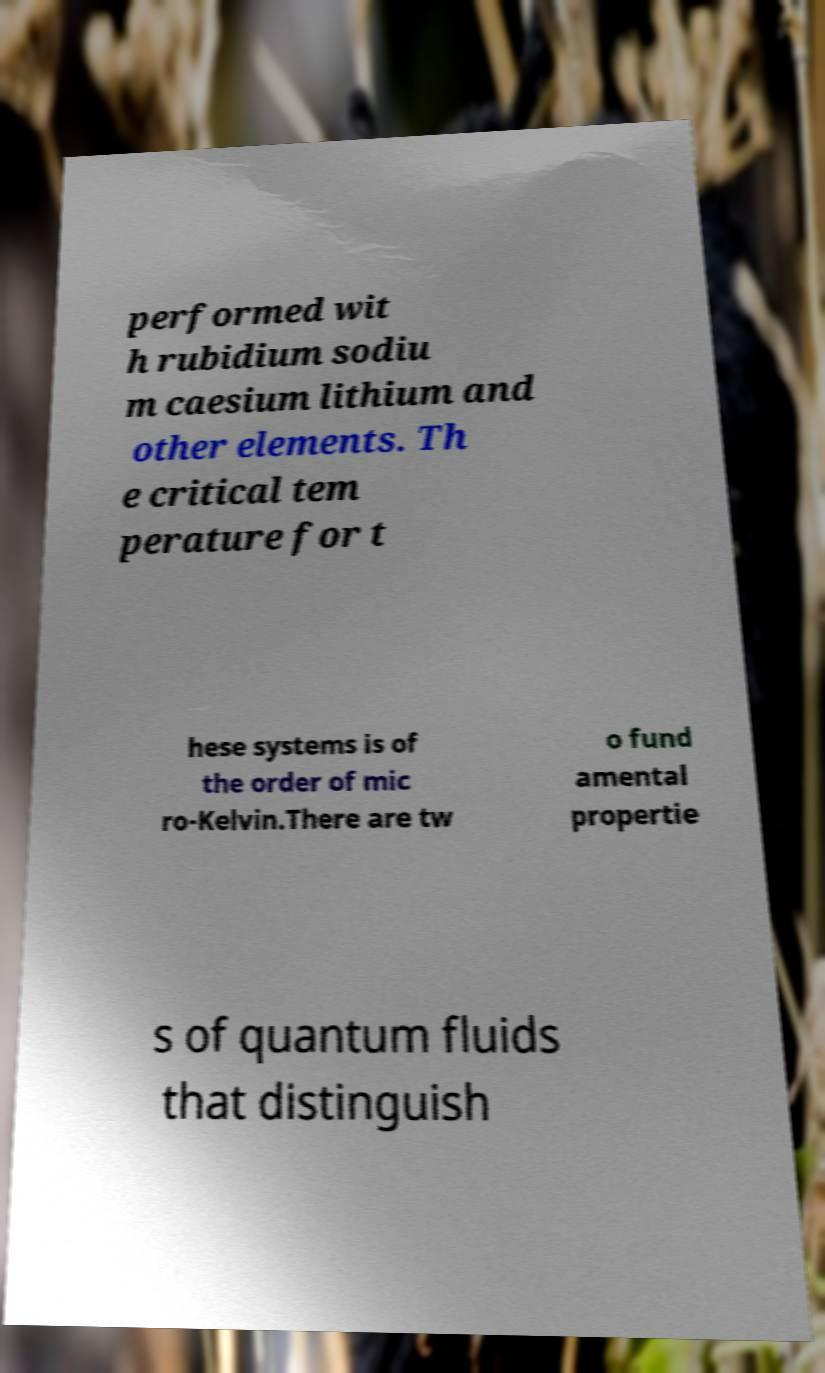Can you read and provide the text displayed in the image?This photo seems to have some interesting text. Can you extract and type it out for me? performed wit h rubidium sodiu m caesium lithium and other elements. Th e critical tem perature for t hese systems is of the order of mic ro-Kelvin.There are tw o fund amental propertie s of quantum fluids that distinguish 